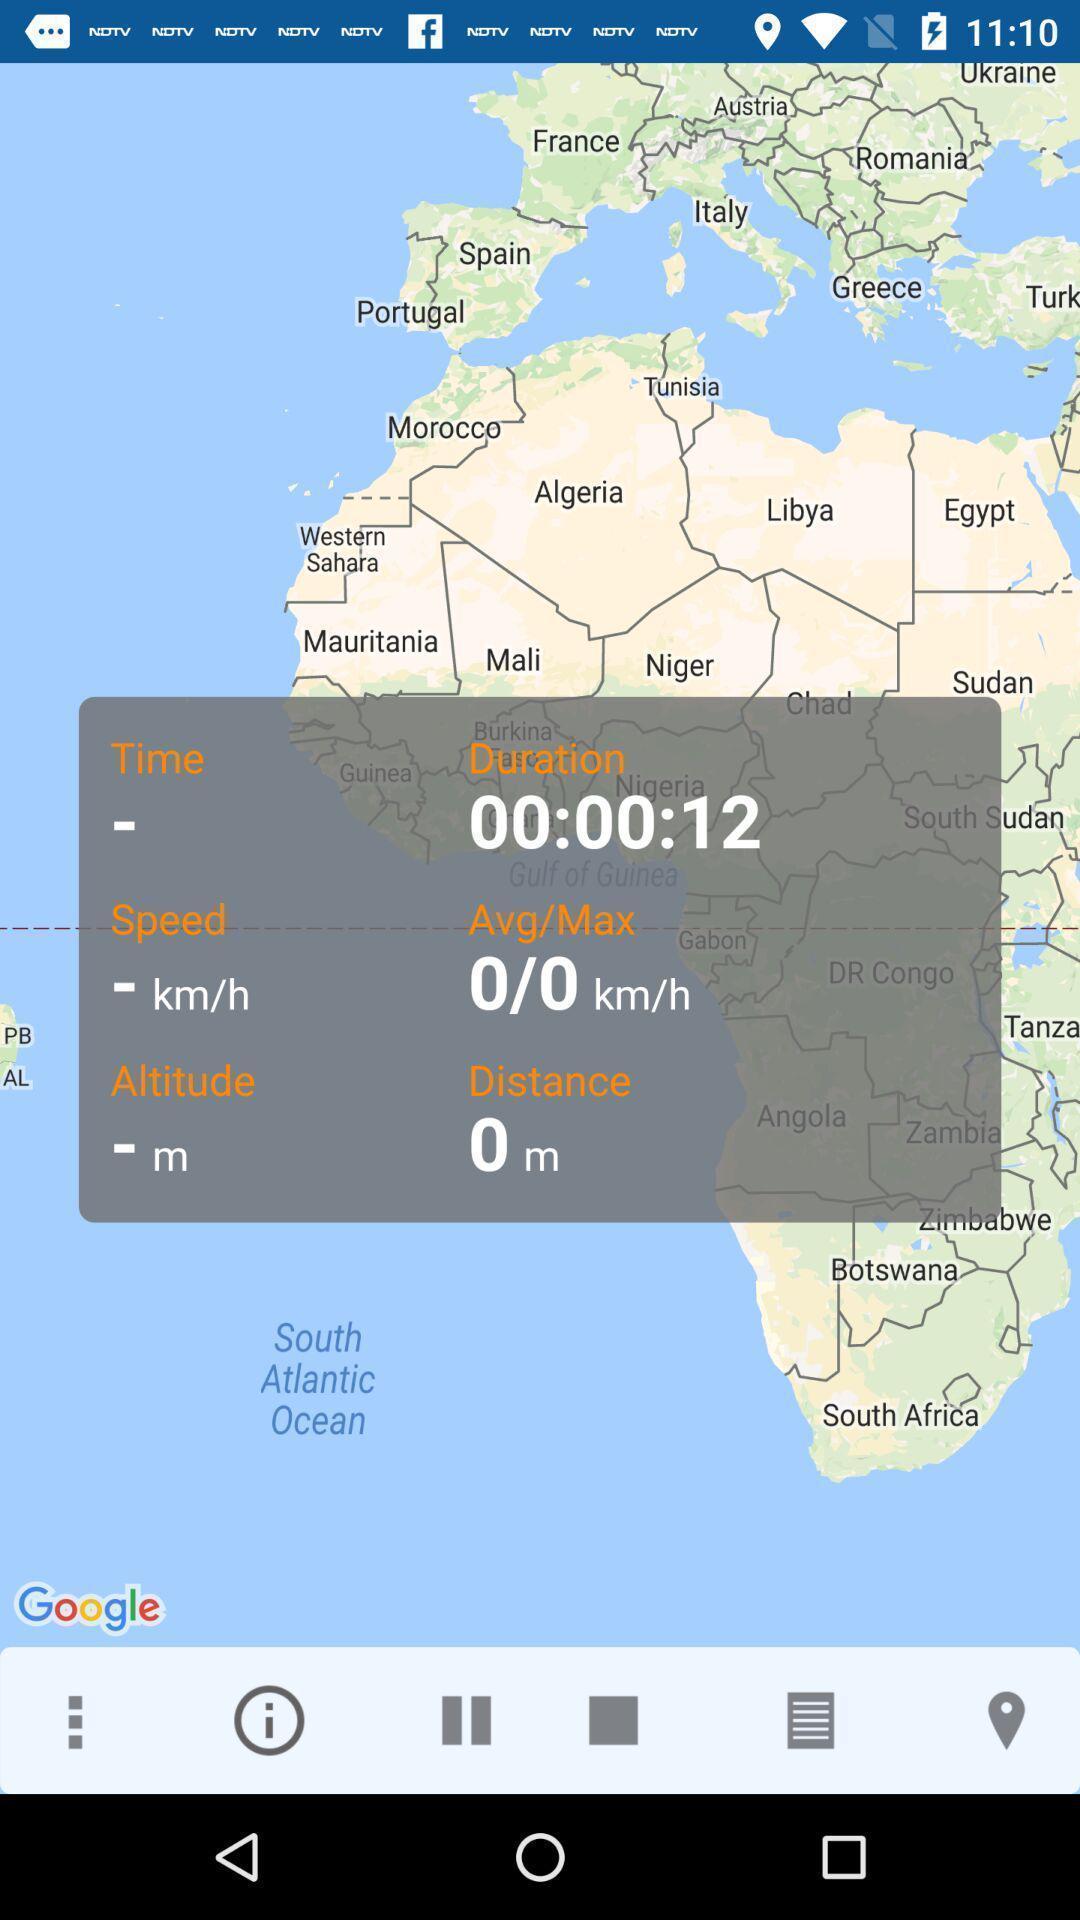Provide a textual representation of this image. Pop-up showing all the details. 